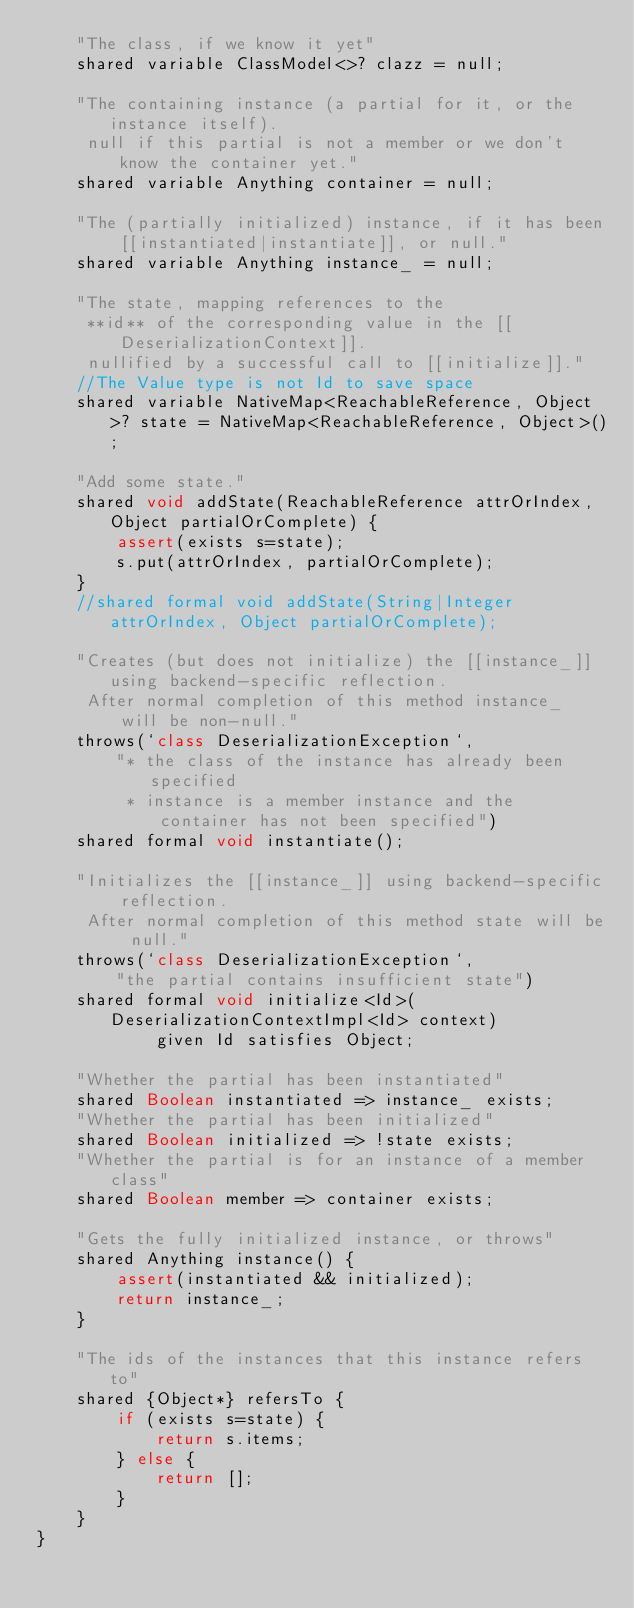Convert code to text. <code><loc_0><loc_0><loc_500><loc_500><_Ceylon_>    "The class, if we know it yet"
    shared variable ClassModel<>? clazz = null;
    
    "The containing instance (a partial for it, or the instance itself).
     null if this partial is not a member or we don't know the container yet."
    shared variable Anything container = null;
    
    "The (partially initialized) instance, if it has been [[instantiated|instantiate]], or null."
    shared variable Anything instance_ = null;
    
    "The state, mapping references to the 
     **id** of the corresponding value in the [[DeserializationContext]].
     nullified by a successful call to [[initialize]]."
    //The Value type is not Id to save space
    shared variable NativeMap<ReachableReference, Object>? state = NativeMap<ReachableReference, Object>();
    
    "Add some state."
    shared void addState(ReachableReference attrOrIndex, Object partialOrComplete) {
        assert(exists s=state);
        s.put(attrOrIndex, partialOrComplete);
    }
    //shared formal void addState(String|Integer attrOrIndex, Object partialOrComplete);
    
    "Creates (but does not initialize) the [[instance_]] using backend-specific reflection.
     After normal completion of this method instance_ will be non-null."
    throws(`class DeserializationException`,
        "* the class of the instance has already been specified
         * instance is a member instance and the container has not been specified")
    shared formal void instantiate();
    
    "Initializes the [[instance_]] using backend-specific reflection.
     After normal completion of this method state will be null."
    throws(`class DeserializationException`,
        "the partial contains insufficient state")
    shared formal void initialize<Id>(DeserializationContextImpl<Id> context)
            given Id satisfies Object;
    
    "Whether the partial has been instantiated"
    shared Boolean instantiated => instance_ exists;
    "Whether the partial has been initialized"
    shared Boolean initialized => !state exists;
    "Whether the partial is for an instance of a member class"
    shared Boolean member => container exists;
    
    "Gets the fully initialized instance, or throws"
    shared Anything instance() {
        assert(instantiated && initialized);
        return instance_;
    }
    
    "The ids of the instances that this instance refers to"
    shared {Object*} refersTo {
        if (exists s=state) {
            return s.items;
        } else {
            return [];
        }
    }
}
</code> 